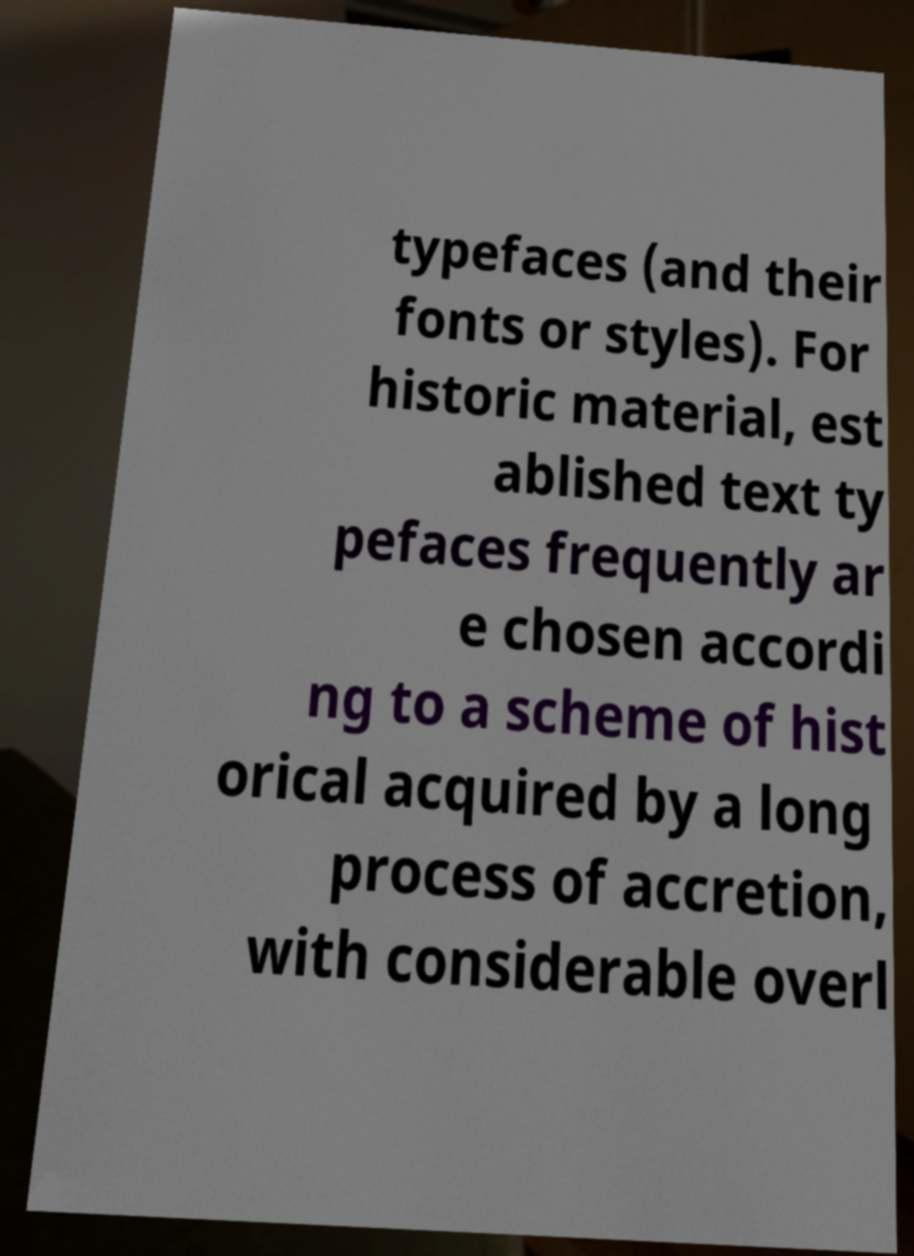Could you extract and type out the text from this image? typefaces (and their fonts or styles). For historic material, est ablished text ty pefaces frequently ar e chosen accordi ng to a scheme of hist orical acquired by a long process of accretion, with considerable overl 